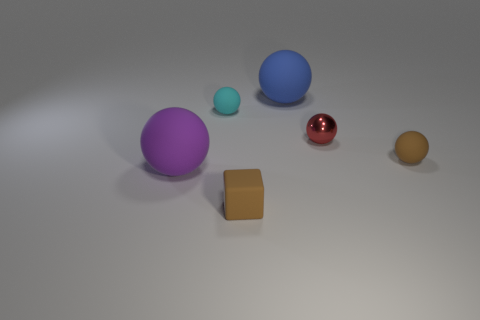Subtract all blue balls. Subtract all brown cubes. How many balls are left? 4 Subtract all brown spheres. How many yellow cubes are left? 0 Add 2 blues. How many tiny cyans exist? 0 Subtract all yellow matte balls. Subtract all purple rubber balls. How many objects are left? 5 Add 1 shiny balls. How many shiny balls are left? 2 Add 6 red metal things. How many red metal things exist? 7 Add 3 large balls. How many objects exist? 9 Subtract all blue balls. How many balls are left? 4 Subtract all tiny brown spheres. How many spheres are left? 4 Subtract 1 red balls. How many objects are left? 5 